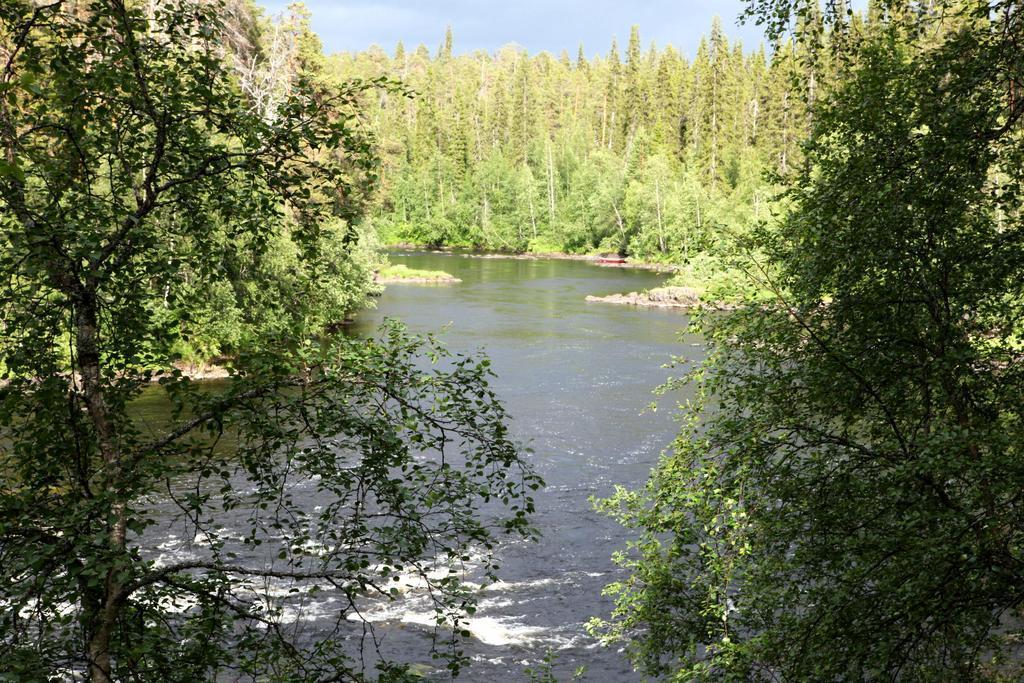Describe this image in one or two sentences. In this image, we can see a lake and in the background, there are trees. 